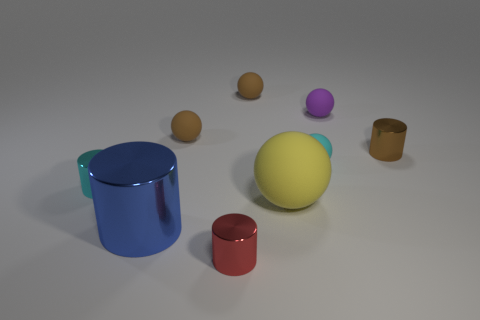Subtract all small brown balls. How many balls are left? 3 Add 1 red cylinders. How many objects exist? 10 Subtract 1 cylinders. How many cylinders are left? 3 Subtract all cyan cylinders. How many brown spheres are left? 2 Subtract all purple spheres. How many spheres are left? 4 Subtract all brown cylinders. Subtract all brown things. How many objects are left? 5 Add 2 red objects. How many red objects are left? 3 Add 4 large red cylinders. How many large red cylinders exist? 4 Subtract 0 gray cylinders. How many objects are left? 9 Subtract all spheres. How many objects are left? 4 